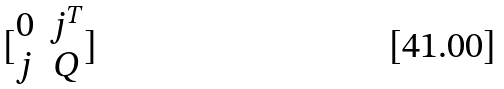<formula> <loc_0><loc_0><loc_500><loc_500>[ \begin{matrix} 0 & j ^ { T } \\ j & Q \end{matrix} ]</formula> 